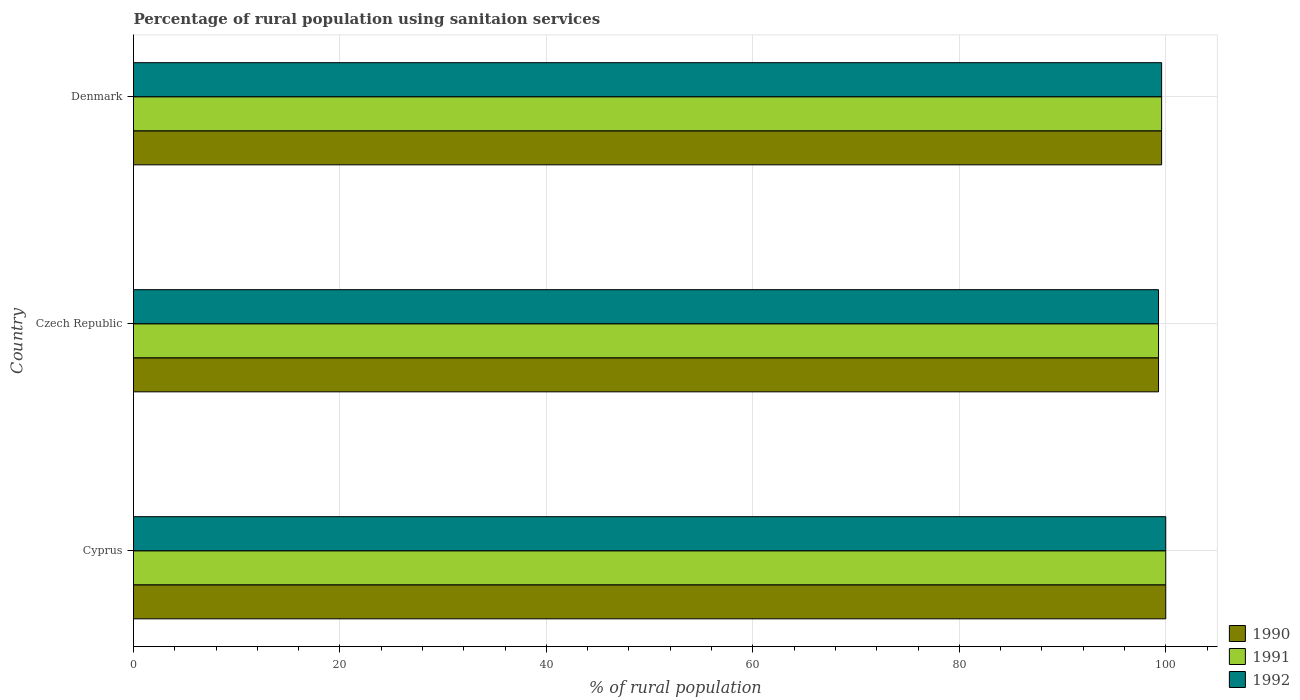How many bars are there on the 1st tick from the top?
Keep it short and to the point. 3. What is the label of the 2nd group of bars from the top?
Provide a short and direct response. Czech Republic. What is the percentage of rural population using sanitaion services in 1991 in Czech Republic?
Provide a succinct answer. 99.3. Across all countries, what is the minimum percentage of rural population using sanitaion services in 1991?
Your answer should be compact. 99.3. In which country was the percentage of rural population using sanitaion services in 1992 maximum?
Provide a short and direct response. Cyprus. In which country was the percentage of rural population using sanitaion services in 1992 minimum?
Ensure brevity in your answer.  Czech Republic. What is the total percentage of rural population using sanitaion services in 1992 in the graph?
Your answer should be compact. 298.9. What is the difference between the percentage of rural population using sanitaion services in 1991 in Czech Republic and that in Denmark?
Your response must be concise. -0.3. What is the difference between the percentage of rural population using sanitaion services in 1991 in Denmark and the percentage of rural population using sanitaion services in 1990 in Cyprus?
Your answer should be very brief. -0.4. What is the average percentage of rural population using sanitaion services in 1990 per country?
Ensure brevity in your answer.  99.63. What is the difference between the percentage of rural population using sanitaion services in 1991 and percentage of rural population using sanitaion services in 1992 in Denmark?
Offer a terse response. 0. In how many countries, is the percentage of rural population using sanitaion services in 1991 greater than 56 %?
Keep it short and to the point. 3. What is the ratio of the percentage of rural population using sanitaion services in 1992 in Czech Republic to that in Denmark?
Offer a terse response. 1. What is the difference between the highest and the second highest percentage of rural population using sanitaion services in 1992?
Your answer should be compact. 0.4. What is the difference between the highest and the lowest percentage of rural population using sanitaion services in 1992?
Offer a very short reply. 0.7. Is the sum of the percentage of rural population using sanitaion services in 1990 in Czech Republic and Denmark greater than the maximum percentage of rural population using sanitaion services in 1992 across all countries?
Keep it short and to the point. Yes. What does the 3rd bar from the top in Denmark represents?
Your response must be concise. 1990. What does the 2nd bar from the bottom in Czech Republic represents?
Provide a short and direct response. 1991. Is it the case that in every country, the sum of the percentage of rural population using sanitaion services in 1991 and percentage of rural population using sanitaion services in 1992 is greater than the percentage of rural population using sanitaion services in 1990?
Offer a terse response. Yes. Are all the bars in the graph horizontal?
Your response must be concise. Yes. What is the difference between two consecutive major ticks on the X-axis?
Offer a terse response. 20. Does the graph contain any zero values?
Give a very brief answer. No. What is the title of the graph?
Provide a succinct answer. Percentage of rural population using sanitaion services. What is the label or title of the X-axis?
Give a very brief answer. % of rural population. What is the % of rural population of 1990 in Czech Republic?
Ensure brevity in your answer.  99.3. What is the % of rural population in 1991 in Czech Republic?
Your answer should be very brief. 99.3. What is the % of rural population of 1992 in Czech Republic?
Ensure brevity in your answer.  99.3. What is the % of rural population of 1990 in Denmark?
Offer a very short reply. 99.6. What is the % of rural population in 1991 in Denmark?
Make the answer very short. 99.6. What is the % of rural population in 1992 in Denmark?
Provide a succinct answer. 99.6. Across all countries, what is the maximum % of rural population in 1990?
Your answer should be compact. 100. Across all countries, what is the maximum % of rural population of 1991?
Offer a terse response. 100. Across all countries, what is the minimum % of rural population of 1990?
Keep it short and to the point. 99.3. Across all countries, what is the minimum % of rural population of 1991?
Make the answer very short. 99.3. Across all countries, what is the minimum % of rural population in 1992?
Your answer should be very brief. 99.3. What is the total % of rural population of 1990 in the graph?
Offer a very short reply. 298.9. What is the total % of rural population of 1991 in the graph?
Offer a very short reply. 298.9. What is the total % of rural population in 1992 in the graph?
Your response must be concise. 298.9. What is the difference between the % of rural population in 1990 in Cyprus and that in Czech Republic?
Make the answer very short. 0.7. What is the difference between the % of rural population in 1992 in Cyprus and that in Czech Republic?
Provide a short and direct response. 0.7. What is the difference between the % of rural population in 1991 in Cyprus and that in Denmark?
Offer a terse response. 0.4. What is the difference between the % of rural population in 1992 in Cyprus and that in Denmark?
Ensure brevity in your answer.  0.4. What is the difference between the % of rural population in 1990 in Czech Republic and that in Denmark?
Make the answer very short. -0.3. What is the difference between the % of rural population of 1991 in Czech Republic and that in Denmark?
Your answer should be very brief. -0.3. What is the difference between the % of rural population of 1992 in Czech Republic and that in Denmark?
Provide a succinct answer. -0.3. What is the difference between the % of rural population in 1991 in Cyprus and the % of rural population in 1992 in Czech Republic?
Provide a succinct answer. 0.7. What is the difference between the % of rural population of 1991 in Czech Republic and the % of rural population of 1992 in Denmark?
Make the answer very short. -0.3. What is the average % of rural population in 1990 per country?
Keep it short and to the point. 99.63. What is the average % of rural population of 1991 per country?
Provide a short and direct response. 99.63. What is the average % of rural population of 1992 per country?
Provide a succinct answer. 99.63. What is the difference between the % of rural population of 1991 and % of rural population of 1992 in Cyprus?
Your response must be concise. 0. What is the difference between the % of rural population in 1990 and % of rural population in 1992 in Czech Republic?
Keep it short and to the point. 0. What is the ratio of the % of rural population of 1990 in Cyprus to that in Czech Republic?
Your response must be concise. 1.01. What is the ratio of the % of rural population in 1992 in Cyprus to that in Czech Republic?
Your answer should be very brief. 1.01. What is the ratio of the % of rural population in 1990 in Czech Republic to that in Denmark?
Your answer should be compact. 1. What is the ratio of the % of rural population of 1991 in Czech Republic to that in Denmark?
Keep it short and to the point. 1. What is the difference between the highest and the second highest % of rural population of 1990?
Provide a succinct answer. 0.4. 